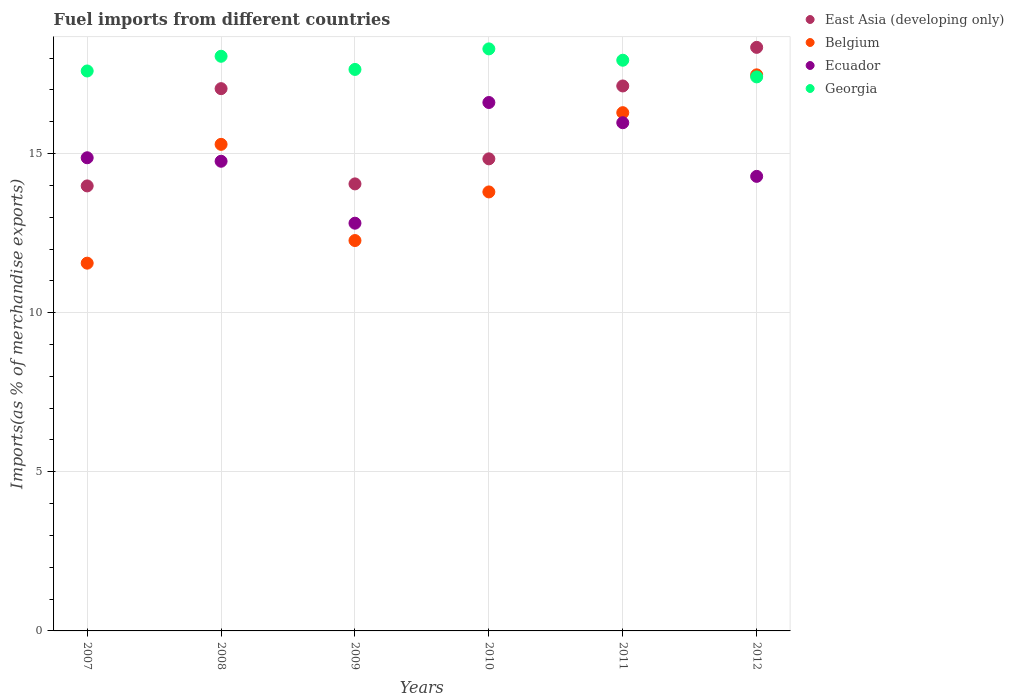Is the number of dotlines equal to the number of legend labels?
Provide a succinct answer. Yes. What is the percentage of imports to different countries in Belgium in 2009?
Your response must be concise. 12.27. Across all years, what is the maximum percentage of imports to different countries in East Asia (developing only)?
Provide a short and direct response. 18.34. Across all years, what is the minimum percentage of imports to different countries in East Asia (developing only)?
Ensure brevity in your answer.  13.98. In which year was the percentage of imports to different countries in Ecuador minimum?
Give a very brief answer. 2009. What is the total percentage of imports to different countries in East Asia (developing only) in the graph?
Provide a succinct answer. 95.36. What is the difference between the percentage of imports to different countries in Ecuador in 2009 and that in 2010?
Offer a terse response. -3.79. What is the difference between the percentage of imports to different countries in Belgium in 2009 and the percentage of imports to different countries in Ecuador in 2008?
Your response must be concise. -2.49. What is the average percentage of imports to different countries in Belgium per year?
Keep it short and to the point. 14.44. In the year 2009, what is the difference between the percentage of imports to different countries in Belgium and percentage of imports to different countries in Ecuador?
Your answer should be compact. -0.54. In how many years, is the percentage of imports to different countries in Ecuador greater than 2 %?
Offer a very short reply. 6. What is the ratio of the percentage of imports to different countries in Belgium in 2007 to that in 2011?
Make the answer very short. 0.71. Is the percentage of imports to different countries in Belgium in 2007 less than that in 2009?
Give a very brief answer. Yes. What is the difference between the highest and the second highest percentage of imports to different countries in Ecuador?
Your answer should be compact. 0.64. What is the difference between the highest and the lowest percentage of imports to different countries in Ecuador?
Your response must be concise. 3.79. Is it the case that in every year, the sum of the percentage of imports to different countries in East Asia (developing only) and percentage of imports to different countries in Belgium  is greater than the sum of percentage of imports to different countries in Ecuador and percentage of imports to different countries in Georgia?
Your response must be concise. No. Does the percentage of imports to different countries in Ecuador monotonically increase over the years?
Keep it short and to the point. No. Is the percentage of imports to different countries in Georgia strictly greater than the percentage of imports to different countries in Ecuador over the years?
Give a very brief answer. Yes. Is the percentage of imports to different countries in Georgia strictly less than the percentage of imports to different countries in East Asia (developing only) over the years?
Offer a terse response. No. How many dotlines are there?
Keep it short and to the point. 4. What is the difference between two consecutive major ticks on the Y-axis?
Your response must be concise. 5. Does the graph contain grids?
Your answer should be compact. Yes. How are the legend labels stacked?
Your answer should be very brief. Vertical. What is the title of the graph?
Provide a short and direct response. Fuel imports from different countries. Does "Faeroe Islands" appear as one of the legend labels in the graph?
Keep it short and to the point. No. What is the label or title of the Y-axis?
Make the answer very short. Imports(as % of merchandise exports). What is the Imports(as % of merchandise exports) of East Asia (developing only) in 2007?
Provide a succinct answer. 13.98. What is the Imports(as % of merchandise exports) of Belgium in 2007?
Make the answer very short. 11.56. What is the Imports(as % of merchandise exports) of Ecuador in 2007?
Your response must be concise. 14.87. What is the Imports(as % of merchandise exports) in Georgia in 2007?
Provide a short and direct response. 17.59. What is the Imports(as % of merchandise exports) of East Asia (developing only) in 2008?
Ensure brevity in your answer.  17.04. What is the Imports(as % of merchandise exports) in Belgium in 2008?
Your answer should be very brief. 15.29. What is the Imports(as % of merchandise exports) in Ecuador in 2008?
Keep it short and to the point. 14.76. What is the Imports(as % of merchandise exports) of Georgia in 2008?
Offer a very short reply. 18.06. What is the Imports(as % of merchandise exports) in East Asia (developing only) in 2009?
Make the answer very short. 14.05. What is the Imports(as % of merchandise exports) of Belgium in 2009?
Your answer should be compact. 12.27. What is the Imports(as % of merchandise exports) of Ecuador in 2009?
Offer a very short reply. 12.81. What is the Imports(as % of merchandise exports) in Georgia in 2009?
Provide a short and direct response. 17.64. What is the Imports(as % of merchandise exports) of East Asia (developing only) in 2010?
Your response must be concise. 14.83. What is the Imports(as % of merchandise exports) in Belgium in 2010?
Your answer should be very brief. 13.79. What is the Imports(as % of merchandise exports) in Ecuador in 2010?
Your answer should be very brief. 16.6. What is the Imports(as % of merchandise exports) in Georgia in 2010?
Keep it short and to the point. 18.29. What is the Imports(as % of merchandise exports) of East Asia (developing only) in 2011?
Provide a short and direct response. 17.12. What is the Imports(as % of merchandise exports) in Belgium in 2011?
Keep it short and to the point. 16.28. What is the Imports(as % of merchandise exports) in Ecuador in 2011?
Make the answer very short. 15.97. What is the Imports(as % of merchandise exports) of Georgia in 2011?
Your response must be concise. 17.93. What is the Imports(as % of merchandise exports) of East Asia (developing only) in 2012?
Give a very brief answer. 18.34. What is the Imports(as % of merchandise exports) in Belgium in 2012?
Your answer should be very brief. 17.47. What is the Imports(as % of merchandise exports) in Ecuador in 2012?
Your answer should be compact. 14.28. What is the Imports(as % of merchandise exports) in Georgia in 2012?
Give a very brief answer. 17.41. Across all years, what is the maximum Imports(as % of merchandise exports) of East Asia (developing only)?
Offer a very short reply. 18.34. Across all years, what is the maximum Imports(as % of merchandise exports) in Belgium?
Give a very brief answer. 17.47. Across all years, what is the maximum Imports(as % of merchandise exports) in Ecuador?
Keep it short and to the point. 16.6. Across all years, what is the maximum Imports(as % of merchandise exports) in Georgia?
Offer a very short reply. 18.29. Across all years, what is the minimum Imports(as % of merchandise exports) in East Asia (developing only)?
Ensure brevity in your answer.  13.98. Across all years, what is the minimum Imports(as % of merchandise exports) in Belgium?
Provide a short and direct response. 11.56. Across all years, what is the minimum Imports(as % of merchandise exports) in Ecuador?
Keep it short and to the point. 12.81. Across all years, what is the minimum Imports(as % of merchandise exports) in Georgia?
Offer a very short reply. 17.41. What is the total Imports(as % of merchandise exports) in East Asia (developing only) in the graph?
Your answer should be very brief. 95.36. What is the total Imports(as % of merchandise exports) in Belgium in the graph?
Provide a short and direct response. 86.66. What is the total Imports(as % of merchandise exports) of Ecuador in the graph?
Keep it short and to the point. 89.29. What is the total Imports(as % of merchandise exports) in Georgia in the graph?
Provide a succinct answer. 106.92. What is the difference between the Imports(as % of merchandise exports) in East Asia (developing only) in 2007 and that in 2008?
Give a very brief answer. -3.06. What is the difference between the Imports(as % of merchandise exports) of Belgium in 2007 and that in 2008?
Ensure brevity in your answer.  -3.73. What is the difference between the Imports(as % of merchandise exports) of Ecuador in 2007 and that in 2008?
Make the answer very short. 0.11. What is the difference between the Imports(as % of merchandise exports) of Georgia in 2007 and that in 2008?
Make the answer very short. -0.46. What is the difference between the Imports(as % of merchandise exports) of East Asia (developing only) in 2007 and that in 2009?
Your response must be concise. -0.06. What is the difference between the Imports(as % of merchandise exports) in Belgium in 2007 and that in 2009?
Your answer should be compact. -0.71. What is the difference between the Imports(as % of merchandise exports) of Ecuador in 2007 and that in 2009?
Your answer should be compact. 2.06. What is the difference between the Imports(as % of merchandise exports) of Georgia in 2007 and that in 2009?
Provide a succinct answer. -0.05. What is the difference between the Imports(as % of merchandise exports) in East Asia (developing only) in 2007 and that in 2010?
Your answer should be compact. -0.85. What is the difference between the Imports(as % of merchandise exports) of Belgium in 2007 and that in 2010?
Give a very brief answer. -2.24. What is the difference between the Imports(as % of merchandise exports) in Ecuador in 2007 and that in 2010?
Provide a short and direct response. -1.74. What is the difference between the Imports(as % of merchandise exports) in Georgia in 2007 and that in 2010?
Offer a terse response. -0.69. What is the difference between the Imports(as % of merchandise exports) in East Asia (developing only) in 2007 and that in 2011?
Your answer should be compact. -3.14. What is the difference between the Imports(as % of merchandise exports) of Belgium in 2007 and that in 2011?
Provide a succinct answer. -4.73. What is the difference between the Imports(as % of merchandise exports) in Ecuador in 2007 and that in 2011?
Your answer should be very brief. -1.1. What is the difference between the Imports(as % of merchandise exports) in Georgia in 2007 and that in 2011?
Give a very brief answer. -0.34. What is the difference between the Imports(as % of merchandise exports) of East Asia (developing only) in 2007 and that in 2012?
Keep it short and to the point. -4.35. What is the difference between the Imports(as % of merchandise exports) in Belgium in 2007 and that in 2012?
Provide a short and direct response. -5.92. What is the difference between the Imports(as % of merchandise exports) of Ecuador in 2007 and that in 2012?
Keep it short and to the point. 0.58. What is the difference between the Imports(as % of merchandise exports) in Georgia in 2007 and that in 2012?
Your answer should be compact. 0.19. What is the difference between the Imports(as % of merchandise exports) in East Asia (developing only) in 2008 and that in 2009?
Your answer should be compact. 2.99. What is the difference between the Imports(as % of merchandise exports) of Belgium in 2008 and that in 2009?
Your answer should be very brief. 3.02. What is the difference between the Imports(as % of merchandise exports) in Ecuador in 2008 and that in 2009?
Provide a succinct answer. 1.95. What is the difference between the Imports(as % of merchandise exports) of Georgia in 2008 and that in 2009?
Your response must be concise. 0.41. What is the difference between the Imports(as % of merchandise exports) of East Asia (developing only) in 2008 and that in 2010?
Keep it short and to the point. 2.21. What is the difference between the Imports(as % of merchandise exports) of Belgium in 2008 and that in 2010?
Make the answer very short. 1.49. What is the difference between the Imports(as % of merchandise exports) in Ecuador in 2008 and that in 2010?
Offer a terse response. -1.85. What is the difference between the Imports(as % of merchandise exports) of Georgia in 2008 and that in 2010?
Your response must be concise. -0.23. What is the difference between the Imports(as % of merchandise exports) in East Asia (developing only) in 2008 and that in 2011?
Offer a terse response. -0.08. What is the difference between the Imports(as % of merchandise exports) in Belgium in 2008 and that in 2011?
Your answer should be compact. -1. What is the difference between the Imports(as % of merchandise exports) in Ecuador in 2008 and that in 2011?
Your answer should be compact. -1.21. What is the difference between the Imports(as % of merchandise exports) of Georgia in 2008 and that in 2011?
Make the answer very short. 0.12. What is the difference between the Imports(as % of merchandise exports) in East Asia (developing only) in 2008 and that in 2012?
Give a very brief answer. -1.3. What is the difference between the Imports(as % of merchandise exports) in Belgium in 2008 and that in 2012?
Give a very brief answer. -2.18. What is the difference between the Imports(as % of merchandise exports) of Ecuador in 2008 and that in 2012?
Make the answer very short. 0.47. What is the difference between the Imports(as % of merchandise exports) in Georgia in 2008 and that in 2012?
Make the answer very short. 0.65. What is the difference between the Imports(as % of merchandise exports) of East Asia (developing only) in 2009 and that in 2010?
Your answer should be very brief. -0.79. What is the difference between the Imports(as % of merchandise exports) of Belgium in 2009 and that in 2010?
Your response must be concise. -1.53. What is the difference between the Imports(as % of merchandise exports) of Ecuador in 2009 and that in 2010?
Provide a short and direct response. -3.79. What is the difference between the Imports(as % of merchandise exports) of Georgia in 2009 and that in 2010?
Offer a very short reply. -0.65. What is the difference between the Imports(as % of merchandise exports) in East Asia (developing only) in 2009 and that in 2011?
Give a very brief answer. -3.08. What is the difference between the Imports(as % of merchandise exports) of Belgium in 2009 and that in 2011?
Your answer should be compact. -4.02. What is the difference between the Imports(as % of merchandise exports) in Ecuador in 2009 and that in 2011?
Provide a succinct answer. -3.16. What is the difference between the Imports(as % of merchandise exports) in Georgia in 2009 and that in 2011?
Ensure brevity in your answer.  -0.29. What is the difference between the Imports(as % of merchandise exports) in East Asia (developing only) in 2009 and that in 2012?
Make the answer very short. -4.29. What is the difference between the Imports(as % of merchandise exports) in Belgium in 2009 and that in 2012?
Give a very brief answer. -5.21. What is the difference between the Imports(as % of merchandise exports) in Ecuador in 2009 and that in 2012?
Offer a terse response. -1.47. What is the difference between the Imports(as % of merchandise exports) in Georgia in 2009 and that in 2012?
Keep it short and to the point. 0.23. What is the difference between the Imports(as % of merchandise exports) in East Asia (developing only) in 2010 and that in 2011?
Keep it short and to the point. -2.29. What is the difference between the Imports(as % of merchandise exports) of Belgium in 2010 and that in 2011?
Your response must be concise. -2.49. What is the difference between the Imports(as % of merchandise exports) in Ecuador in 2010 and that in 2011?
Provide a succinct answer. 0.64. What is the difference between the Imports(as % of merchandise exports) of Georgia in 2010 and that in 2011?
Your response must be concise. 0.36. What is the difference between the Imports(as % of merchandise exports) of East Asia (developing only) in 2010 and that in 2012?
Provide a short and direct response. -3.5. What is the difference between the Imports(as % of merchandise exports) of Belgium in 2010 and that in 2012?
Your response must be concise. -3.68. What is the difference between the Imports(as % of merchandise exports) in Ecuador in 2010 and that in 2012?
Ensure brevity in your answer.  2.32. What is the difference between the Imports(as % of merchandise exports) of Georgia in 2010 and that in 2012?
Provide a succinct answer. 0.88. What is the difference between the Imports(as % of merchandise exports) in East Asia (developing only) in 2011 and that in 2012?
Your response must be concise. -1.21. What is the difference between the Imports(as % of merchandise exports) of Belgium in 2011 and that in 2012?
Make the answer very short. -1.19. What is the difference between the Imports(as % of merchandise exports) of Ecuador in 2011 and that in 2012?
Your response must be concise. 1.69. What is the difference between the Imports(as % of merchandise exports) in Georgia in 2011 and that in 2012?
Provide a short and direct response. 0.52. What is the difference between the Imports(as % of merchandise exports) in East Asia (developing only) in 2007 and the Imports(as % of merchandise exports) in Belgium in 2008?
Keep it short and to the point. -1.31. What is the difference between the Imports(as % of merchandise exports) of East Asia (developing only) in 2007 and the Imports(as % of merchandise exports) of Ecuador in 2008?
Provide a succinct answer. -0.78. What is the difference between the Imports(as % of merchandise exports) of East Asia (developing only) in 2007 and the Imports(as % of merchandise exports) of Georgia in 2008?
Keep it short and to the point. -4.07. What is the difference between the Imports(as % of merchandise exports) in Belgium in 2007 and the Imports(as % of merchandise exports) in Ecuador in 2008?
Offer a terse response. -3.2. What is the difference between the Imports(as % of merchandise exports) of Belgium in 2007 and the Imports(as % of merchandise exports) of Georgia in 2008?
Ensure brevity in your answer.  -6.5. What is the difference between the Imports(as % of merchandise exports) in Ecuador in 2007 and the Imports(as % of merchandise exports) in Georgia in 2008?
Your response must be concise. -3.19. What is the difference between the Imports(as % of merchandise exports) in East Asia (developing only) in 2007 and the Imports(as % of merchandise exports) in Belgium in 2009?
Keep it short and to the point. 1.72. What is the difference between the Imports(as % of merchandise exports) of East Asia (developing only) in 2007 and the Imports(as % of merchandise exports) of Ecuador in 2009?
Your response must be concise. 1.17. What is the difference between the Imports(as % of merchandise exports) in East Asia (developing only) in 2007 and the Imports(as % of merchandise exports) in Georgia in 2009?
Your answer should be very brief. -3.66. What is the difference between the Imports(as % of merchandise exports) of Belgium in 2007 and the Imports(as % of merchandise exports) of Ecuador in 2009?
Offer a terse response. -1.26. What is the difference between the Imports(as % of merchandise exports) of Belgium in 2007 and the Imports(as % of merchandise exports) of Georgia in 2009?
Offer a terse response. -6.09. What is the difference between the Imports(as % of merchandise exports) in Ecuador in 2007 and the Imports(as % of merchandise exports) in Georgia in 2009?
Provide a short and direct response. -2.78. What is the difference between the Imports(as % of merchandise exports) in East Asia (developing only) in 2007 and the Imports(as % of merchandise exports) in Belgium in 2010?
Give a very brief answer. 0.19. What is the difference between the Imports(as % of merchandise exports) of East Asia (developing only) in 2007 and the Imports(as % of merchandise exports) of Ecuador in 2010?
Ensure brevity in your answer.  -2.62. What is the difference between the Imports(as % of merchandise exports) of East Asia (developing only) in 2007 and the Imports(as % of merchandise exports) of Georgia in 2010?
Keep it short and to the point. -4.31. What is the difference between the Imports(as % of merchandise exports) in Belgium in 2007 and the Imports(as % of merchandise exports) in Ecuador in 2010?
Provide a short and direct response. -5.05. What is the difference between the Imports(as % of merchandise exports) in Belgium in 2007 and the Imports(as % of merchandise exports) in Georgia in 2010?
Your answer should be very brief. -6.73. What is the difference between the Imports(as % of merchandise exports) in Ecuador in 2007 and the Imports(as % of merchandise exports) in Georgia in 2010?
Provide a short and direct response. -3.42. What is the difference between the Imports(as % of merchandise exports) in East Asia (developing only) in 2007 and the Imports(as % of merchandise exports) in Belgium in 2011?
Offer a terse response. -2.3. What is the difference between the Imports(as % of merchandise exports) of East Asia (developing only) in 2007 and the Imports(as % of merchandise exports) of Ecuador in 2011?
Provide a succinct answer. -1.99. What is the difference between the Imports(as % of merchandise exports) in East Asia (developing only) in 2007 and the Imports(as % of merchandise exports) in Georgia in 2011?
Ensure brevity in your answer.  -3.95. What is the difference between the Imports(as % of merchandise exports) of Belgium in 2007 and the Imports(as % of merchandise exports) of Ecuador in 2011?
Ensure brevity in your answer.  -4.41. What is the difference between the Imports(as % of merchandise exports) in Belgium in 2007 and the Imports(as % of merchandise exports) in Georgia in 2011?
Provide a short and direct response. -6.38. What is the difference between the Imports(as % of merchandise exports) of Ecuador in 2007 and the Imports(as % of merchandise exports) of Georgia in 2011?
Your answer should be compact. -3.06. What is the difference between the Imports(as % of merchandise exports) in East Asia (developing only) in 2007 and the Imports(as % of merchandise exports) in Belgium in 2012?
Keep it short and to the point. -3.49. What is the difference between the Imports(as % of merchandise exports) in East Asia (developing only) in 2007 and the Imports(as % of merchandise exports) in Ecuador in 2012?
Your answer should be compact. -0.3. What is the difference between the Imports(as % of merchandise exports) of East Asia (developing only) in 2007 and the Imports(as % of merchandise exports) of Georgia in 2012?
Offer a very short reply. -3.43. What is the difference between the Imports(as % of merchandise exports) in Belgium in 2007 and the Imports(as % of merchandise exports) in Ecuador in 2012?
Ensure brevity in your answer.  -2.73. What is the difference between the Imports(as % of merchandise exports) of Belgium in 2007 and the Imports(as % of merchandise exports) of Georgia in 2012?
Ensure brevity in your answer.  -5.85. What is the difference between the Imports(as % of merchandise exports) in Ecuador in 2007 and the Imports(as % of merchandise exports) in Georgia in 2012?
Give a very brief answer. -2.54. What is the difference between the Imports(as % of merchandise exports) of East Asia (developing only) in 2008 and the Imports(as % of merchandise exports) of Belgium in 2009?
Your answer should be very brief. 4.77. What is the difference between the Imports(as % of merchandise exports) in East Asia (developing only) in 2008 and the Imports(as % of merchandise exports) in Ecuador in 2009?
Offer a very short reply. 4.23. What is the difference between the Imports(as % of merchandise exports) of East Asia (developing only) in 2008 and the Imports(as % of merchandise exports) of Georgia in 2009?
Ensure brevity in your answer.  -0.6. What is the difference between the Imports(as % of merchandise exports) of Belgium in 2008 and the Imports(as % of merchandise exports) of Ecuador in 2009?
Offer a very short reply. 2.48. What is the difference between the Imports(as % of merchandise exports) in Belgium in 2008 and the Imports(as % of merchandise exports) in Georgia in 2009?
Give a very brief answer. -2.35. What is the difference between the Imports(as % of merchandise exports) of Ecuador in 2008 and the Imports(as % of merchandise exports) of Georgia in 2009?
Give a very brief answer. -2.89. What is the difference between the Imports(as % of merchandise exports) in East Asia (developing only) in 2008 and the Imports(as % of merchandise exports) in Belgium in 2010?
Ensure brevity in your answer.  3.24. What is the difference between the Imports(as % of merchandise exports) of East Asia (developing only) in 2008 and the Imports(as % of merchandise exports) of Ecuador in 2010?
Your response must be concise. 0.44. What is the difference between the Imports(as % of merchandise exports) of East Asia (developing only) in 2008 and the Imports(as % of merchandise exports) of Georgia in 2010?
Your answer should be very brief. -1.25. What is the difference between the Imports(as % of merchandise exports) in Belgium in 2008 and the Imports(as % of merchandise exports) in Ecuador in 2010?
Make the answer very short. -1.31. What is the difference between the Imports(as % of merchandise exports) of Belgium in 2008 and the Imports(as % of merchandise exports) of Georgia in 2010?
Provide a short and direct response. -3. What is the difference between the Imports(as % of merchandise exports) of Ecuador in 2008 and the Imports(as % of merchandise exports) of Georgia in 2010?
Offer a terse response. -3.53. What is the difference between the Imports(as % of merchandise exports) in East Asia (developing only) in 2008 and the Imports(as % of merchandise exports) in Belgium in 2011?
Your answer should be very brief. 0.75. What is the difference between the Imports(as % of merchandise exports) of East Asia (developing only) in 2008 and the Imports(as % of merchandise exports) of Ecuador in 2011?
Keep it short and to the point. 1.07. What is the difference between the Imports(as % of merchandise exports) in East Asia (developing only) in 2008 and the Imports(as % of merchandise exports) in Georgia in 2011?
Provide a short and direct response. -0.89. What is the difference between the Imports(as % of merchandise exports) in Belgium in 2008 and the Imports(as % of merchandise exports) in Ecuador in 2011?
Your response must be concise. -0.68. What is the difference between the Imports(as % of merchandise exports) of Belgium in 2008 and the Imports(as % of merchandise exports) of Georgia in 2011?
Give a very brief answer. -2.64. What is the difference between the Imports(as % of merchandise exports) in Ecuador in 2008 and the Imports(as % of merchandise exports) in Georgia in 2011?
Offer a very short reply. -3.17. What is the difference between the Imports(as % of merchandise exports) of East Asia (developing only) in 2008 and the Imports(as % of merchandise exports) of Belgium in 2012?
Ensure brevity in your answer.  -0.43. What is the difference between the Imports(as % of merchandise exports) of East Asia (developing only) in 2008 and the Imports(as % of merchandise exports) of Ecuador in 2012?
Ensure brevity in your answer.  2.76. What is the difference between the Imports(as % of merchandise exports) of East Asia (developing only) in 2008 and the Imports(as % of merchandise exports) of Georgia in 2012?
Your answer should be very brief. -0.37. What is the difference between the Imports(as % of merchandise exports) in Belgium in 2008 and the Imports(as % of merchandise exports) in Georgia in 2012?
Your response must be concise. -2.12. What is the difference between the Imports(as % of merchandise exports) in Ecuador in 2008 and the Imports(as % of merchandise exports) in Georgia in 2012?
Provide a succinct answer. -2.65. What is the difference between the Imports(as % of merchandise exports) of East Asia (developing only) in 2009 and the Imports(as % of merchandise exports) of Belgium in 2010?
Your response must be concise. 0.25. What is the difference between the Imports(as % of merchandise exports) in East Asia (developing only) in 2009 and the Imports(as % of merchandise exports) in Ecuador in 2010?
Keep it short and to the point. -2.56. What is the difference between the Imports(as % of merchandise exports) in East Asia (developing only) in 2009 and the Imports(as % of merchandise exports) in Georgia in 2010?
Make the answer very short. -4.24. What is the difference between the Imports(as % of merchandise exports) of Belgium in 2009 and the Imports(as % of merchandise exports) of Ecuador in 2010?
Make the answer very short. -4.34. What is the difference between the Imports(as % of merchandise exports) in Belgium in 2009 and the Imports(as % of merchandise exports) in Georgia in 2010?
Give a very brief answer. -6.02. What is the difference between the Imports(as % of merchandise exports) of Ecuador in 2009 and the Imports(as % of merchandise exports) of Georgia in 2010?
Your response must be concise. -5.48. What is the difference between the Imports(as % of merchandise exports) in East Asia (developing only) in 2009 and the Imports(as % of merchandise exports) in Belgium in 2011?
Your answer should be compact. -2.24. What is the difference between the Imports(as % of merchandise exports) in East Asia (developing only) in 2009 and the Imports(as % of merchandise exports) in Ecuador in 2011?
Offer a terse response. -1.92. What is the difference between the Imports(as % of merchandise exports) of East Asia (developing only) in 2009 and the Imports(as % of merchandise exports) of Georgia in 2011?
Ensure brevity in your answer.  -3.89. What is the difference between the Imports(as % of merchandise exports) of Belgium in 2009 and the Imports(as % of merchandise exports) of Ecuador in 2011?
Offer a very short reply. -3.7. What is the difference between the Imports(as % of merchandise exports) in Belgium in 2009 and the Imports(as % of merchandise exports) in Georgia in 2011?
Your answer should be very brief. -5.67. What is the difference between the Imports(as % of merchandise exports) of Ecuador in 2009 and the Imports(as % of merchandise exports) of Georgia in 2011?
Offer a very short reply. -5.12. What is the difference between the Imports(as % of merchandise exports) in East Asia (developing only) in 2009 and the Imports(as % of merchandise exports) in Belgium in 2012?
Your answer should be compact. -3.43. What is the difference between the Imports(as % of merchandise exports) in East Asia (developing only) in 2009 and the Imports(as % of merchandise exports) in Ecuador in 2012?
Your answer should be very brief. -0.24. What is the difference between the Imports(as % of merchandise exports) of East Asia (developing only) in 2009 and the Imports(as % of merchandise exports) of Georgia in 2012?
Your answer should be compact. -3.36. What is the difference between the Imports(as % of merchandise exports) in Belgium in 2009 and the Imports(as % of merchandise exports) in Ecuador in 2012?
Your answer should be compact. -2.02. What is the difference between the Imports(as % of merchandise exports) in Belgium in 2009 and the Imports(as % of merchandise exports) in Georgia in 2012?
Your answer should be compact. -5.14. What is the difference between the Imports(as % of merchandise exports) in Ecuador in 2009 and the Imports(as % of merchandise exports) in Georgia in 2012?
Your answer should be very brief. -4.6. What is the difference between the Imports(as % of merchandise exports) in East Asia (developing only) in 2010 and the Imports(as % of merchandise exports) in Belgium in 2011?
Keep it short and to the point. -1.45. What is the difference between the Imports(as % of merchandise exports) in East Asia (developing only) in 2010 and the Imports(as % of merchandise exports) in Ecuador in 2011?
Keep it short and to the point. -1.14. What is the difference between the Imports(as % of merchandise exports) of East Asia (developing only) in 2010 and the Imports(as % of merchandise exports) of Georgia in 2011?
Ensure brevity in your answer.  -3.1. What is the difference between the Imports(as % of merchandise exports) in Belgium in 2010 and the Imports(as % of merchandise exports) in Ecuador in 2011?
Offer a terse response. -2.17. What is the difference between the Imports(as % of merchandise exports) in Belgium in 2010 and the Imports(as % of merchandise exports) in Georgia in 2011?
Your answer should be compact. -4.14. What is the difference between the Imports(as % of merchandise exports) of Ecuador in 2010 and the Imports(as % of merchandise exports) of Georgia in 2011?
Offer a terse response. -1.33. What is the difference between the Imports(as % of merchandise exports) of East Asia (developing only) in 2010 and the Imports(as % of merchandise exports) of Belgium in 2012?
Provide a succinct answer. -2.64. What is the difference between the Imports(as % of merchandise exports) in East Asia (developing only) in 2010 and the Imports(as % of merchandise exports) in Ecuador in 2012?
Keep it short and to the point. 0.55. What is the difference between the Imports(as % of merchandise exports) of East Asia (developing only) in 2010 and the Imports(as % of merchandise exports) of Georgia in 2012?
Give a very brief answer. -2.58. What is the difference between the Imports(as % of merchandise exports) in Belgium in 2010 and the Imports(as % of merchandise exports) in Ecuador in 2012?
Offer a very short reply. -0.49. What is the difference between the Imports(as % of merchandise exports) in Belgium in 2010 and the Imports(as % of merchandise exports) in Georgia in 2012?
Your answer should be compact. -3.61. What is the difference between the Imports(as % of merchandise exports) of Ecuador in 2010 and the Imports(as % of merchandise exports) of Georgia in 2012?
Keep it short and to the point. -0.8. What is the difference between the Imports(as % of merchandise exports) in East Asia (developing only) in 2011 and the Imports(as % of merchandise exports) in Belgium in 2012?
Give a very brief answer. -0.35. What is the difference between the Imports(as % of merchandise exports) in East Asia (developing only) in 2011 and the Imports(as % of merchandise exports) in Ecuador in 2012?
Offer a terse response. 2.84. What is the difference between the Imports(as % of merchandise exports) of East Asia (developing only) in 2011 and the Imports(as % of merchandise exports) of Georgia in 2012?
Provide a succinct answer. -0.28. What is the difference between the Imports(as % of merchandise exports) of Belgium in 2011 and the Imports(as % of merchandise exports) of Ecuador in 2012?
Provide a succinct answer. 2. What is the difference between the Imports(as % of merchandise exports) of Belgium in 2011 and the Imports(as % of merchandise exports) of Georgia in 2012?
Make the answer very short. -1.12. What is the difference between the Imports(as % of merchandise exports) of Ecuador in 2011 and the Imports(as % of merchandise exports) of Georgia in 2012?
Make the answer very short. -1.44. What is the average Imports(as % of merchandise exports) of East Asia (developing only) per year?
Provide a succinct answer. 15.89. What is the average Imports(as % of merchandise exports) in Belgium per year?
Your response must be concise. 14.44. What is the average Imports(as % of merchandise exports) in Ecuador per year?
Offer a terse response. 14.88. What is the average Imports(as % of merchandise exports) of Georgia per year?
Provide a succinct answer. 17.82. In the year 2007, what is the difference between the Imports(as % of merchandise exports) in East Asia (developing only) and Imports(as % of merchandise exports) in Belgium?
Your response must be concise. 2.43. In the year 2007, what is the difference between the Imports(as % of merchandise exports) in East Asia (developing only) and Imports(as % of merchandise exports) in Ecuador?
Your answer should be compact. -0.88. In the year 2007, what is the difference between the Imports(as % of merchandise exports) of East Asia (developing only) and Imports(as % of merchandise exports) of Georgia?
Your answer should be very brief. -3.61. In the year 2007, what is the difference between the Imports(as % of merchandise exports) in Belgium and Imports(as % of merchandise exports) in Ecuador?
Your answer should be compact. -3.31. In the year 2007, what is the difference between the Imports(as % of merchandise exports) in Belgium and Imports(as % of merchandise exports) in Georgia?
Ensure brevity in your answer.  -6.04. In the year 2007, what is the difference between the Imports(as % of merchandise exports) in Ecuador and Imports(as % of merchandise exports) in Georgia?
Give a very brief answer. -2.73. In the year 2008, what is the difference between the Imports(as % of merchandise exports) of East Asia (developing only) and Imports(as % of merchandise exports) of Belgium?
Your answer should be compact. 1.75. In the year 2008, what is the difference between the Imports(as % of merchandise exports) of East Asia (developing only) and Imports(as % of merchandise exports) of Ecuador?
Your answer should be compact. 2.28. In the year 2008, what is the difference between the Imports(as % of merchandise exports) of East Asia (developing only) and Imports(as % of merchandise exports) of Georgia?
Your answer should be very brief. -1.02. In the year 2008, what is the difference between the Imports(as % of merchandise exports) of Belgium and Imports(as % of merchandise exports) of Ecuador?
Keep it short and to the point. 0.53. In the year 2008, what is the difference between the Imports(as % of merchandise exports) in Belgium and Imports(as % of merchandise exports) in Georgia?
Your answer should be compact. -2.77. In the year 2008, what is the difference between the Imports(as % of merchandise exports) of Ecuador and Imports(as % of merchandise exports) of Georgia?
Your response must be concise. -3.3. In the year 2009, what is the difference between the Imports(as % of merchandise exports) in East Asia (developing only) and Imports(as % of merchandise exports) in Belgium?
Make the answer very short. 1.78. In the year 2009, what is the difference between the Imports(as % of merchandise exports) of East Asia (developing only) and Imports(as % of merchandise exports) of Ecuador?
Keep it short and to the point. 1.23. In the year 2009, what is the difference between the Imports(as % of merchandise exports) in East Asia (developing only) and Imports(as % of merchandise exports) in Georgia?
Make the answer very short. -3.6. In the year 2009, what is the difference between the Imports(as % of merchandise exports) of Belgium and Imports(as % of merchandise exports) of Ecuador?
Give a very brief answer. -0.54. In the year 2009, what is the difference between the Imports(as % of merchandise exports) in Belgium and Imports(as % of merchandise exports) in Georgia?
Make the answer very short. -5.38. In the year 2009, what is the difference between the Imports(as % of merchandise exports) in Ecuador and Imports(as % of merchandise exports) in Georgia?
Your answer should be compact. -4.83. In the year 2010, what is the difference between the Imports(as % of merchandise exports) of East Asia (developing only) and Imports(as % of merchandise exports) of Belgium?
Provide a succinct answer. 1.04. In the year 2010, what is the difference between the Imports(as % of merchandise exports) of East Asia (developing only) and Imports(as % of merchandise exports) of Ecuador?
Your response must be concise. -1.77. In the year 2010, what is the difference between the Imports(as % of merchandise exports) in East Asia (developing only) and Imports(as % of merchandise exports) in Georgia?
Make the answer very short. -3.46. In the year 2010, what is the difference between the Imports(as % of merchandise exports) of Belgium and Imports(as % of merchandise exports) of Ecuador?
Your response must be concise. -2.81. In the year 2010, what is the difference between the Imports(as % of merchandise exports) in Belgium and Imports(as % of merchandise exports) in Georgia?
Give a very brief answer. -4.49. In the year 2010, what is the difference between the Imports(as % of merchandise exports) in Ecuador and Imports(as % of merchandise exports) in Georgia?
Provide a succinct answer. -1.68. In the year 2011, what is the difference between the Imports(as % of merchandise exports) of East Asia (developing only) and Imports(as % of merchandise exports) of Belgium?
Offer a terse response. 0.84. In the year 2011, what is the difference between the Imports(as % of merchandise exports) of East Asia (developing only) and Imports(as % of merchandise exports) of Ecuador?
Offer a very short reply. 1.15. In the year 2011, what is the difference between the Imports(as % of merchandise exports) of East Asia (developing only) and Imports(as % of merchandise exports) of Georgia?
Provide a short and direct response. -0.81. In the year 2011, what is the difference between the Imports(as % of merchandise exports) of Belgium and Imports(as % of merchandise exports) of Ecuador?
Offer a very short reply. 0.32. In the year 2011, what is the difference between the Imports(as % of merchandise exports) in Belgium and Imports(as % of merchandise exports) in Georgia?
Keep it short and to the point. -1.65. In the year 2011, what is the difference between the Imports(as % of merchandise exports) of Ecuador and Imports(as % of merchandise exports) of Georgia?
Offer a very short reply. -1.96. In the year 2012, what is the difference between the Imports(as % of merchandise exports) of East Asia (developing only) and Imports(as % of merchandise exports) of Belgium?
Give a very brief answer. 0.86. In the year 2012, what is the difference between the Imports(as % of merchandise exports) in East Asia (developing only) and Imports(as % of merchandise exports) in Ecuador?
Provide a succinct answer. 4.05. In the year 2012, what is the difference between the Imports(as % of merchandise exports) of East Asia (developing only) and Imports(as % of merchandise exports) of Georgia?
Provide a succinct answer. 0.93. In the year 2012, what is the difference between the Imports(as % of merchandise exports) in Belgium and Imports(as % of merchandise exports) in Ecuador?
Offer a very short reply. 3.19. In the year 2012, what is the difference between the Imports(as % of merchandise exports) in Belgium and Imports(as % of merchandise exports) in Georgia?
Keep it short and to the point. 0.06. In the year 2012, what is the difference between the Imports(as % of merchandise exports) of Ecuador and Imports(as % of merchandise exports) of Georgia?
Give a very brief answer. -3.13. What is the ratio of the Imports(as % of merchandise exports) of East Asia (developing only) in 2007 to that in 2008?
Your response must be concise. 0.82. What is the ratio of the Imports(as % of merchandise exports) of Belgium in 2007 to that in 2008?
Offer a terse response. 0.76. What is the ratio of the Imports(as % of merchandise exports) of Ecuador in 2007 to that in 2008?
Ensure brevity in your answer.  1.01. What is the ratio of the Imports(as % of merchandise exports) in Georgia in 2007 to that in 2008?
Provide a succinct answer. 0.97. What is the ratio of the Imports(as % of merchandise exports) in Belgium in 2007 to that in 2009?
Ensure brevity in your answer.  0.94. What is the ratio of the Imports(as % of merchandise exports) in Ecuador in 2007 to that in 2009?
Provide a succinct answer. 1.16. What is the ratio of the Imports(as % of merchandise exports) of East Asia (developing only) in 2007 to that in 2010?
Your answer should be compact. 0.94. What is the ratio of the Imports(as % of merchandise exports) of Belgium in 2007 to that in 2010?
Give a very brief answer. 0.84. What is the ratio of the Imports(as % of merchandise exports) in Ecuador in 2007 to that in 2010?
Give a very brief answer. 0.9. What is the ratio of the Imports(as % of merchandise exports) of Georgia in 2007 to that in 2010?
Provide a succinct answer. 0.96. What is the ratio of the Imports(as % of merchandise exports) of East Asia (developing only) in 2007 to that in 2011?
Keep it short and to the point. 0.82. What is the ratio of the Imports(as % of merchandise exports) in Belgium in 2007 to that in 2011?
Ensure brevity in your answer.  0.71. What is the ratio of the Imports(as % of merchandise exports) of Georgia in 2007 to that in 2011?
Your answer should be very brief. 0.98. What is the ratio of the Imports(as % of merchandise exports) of East Asia (developing only) in 2007 to that in 2012?
Your response must be concise. 0.76. What is the ratio of the Imports(as % of merchandise exports) in Belgium in 2007 to that in 2012?
Give a very brief answer. 0.66. What is the ratio of the Imports(as % of merchandise exports) in Ecuador in 2007 to that in 2012?
Provide a succinct answer. 1.04. What is the ratio of the Imports(as % of merchandise exports) in Georgia in 2007 to that in 2012?
Offer a very short reply. 1.01. What is the ratio of the Imports(as % of merchandise exports) of East Asia (developing only) in 2008 to that in 2009?
Give a very brief answer. 1.21. What is the ratio of the Imports(as % of merchandise exports) of Belgium in 2008 to that in 2009?
Your answer should be very brief. 1.25. What is the ratio of the Imports(as % of merchandise exports) in Ecuador in 2008 to that in 2009?
Make the answer very short. 1.15. What is the ratio of the Imports(as % of merchandise exports) of Georgia in 2008 to that in 2009?
Provide a succinct answer. 1.02. What is the ratio of the Imports(as % of merchandise exports) of East Asia (developing only) in 2008 to that in 2010?
Ensure brevity in your answer.  1.15. What is the ratio of the Imports(as % of merchandise exports) of Belgium in 2008 to that in 2010?
Make the answer very short. 1.11. What is the ratio of the Imports(as % of merchandise exports) of Ecuador in 2008 to that in 2010?
Offer a very short reply. 0.89. What is the ratio of the Imports(as % of merchandise exports) of Georgia in 2008 to that in 2010?
Ensure brevity in your answer.  0.99. What is the ratio of the Imports(as % of merchandise exports) of East Asia (developing only) in 2008 to that in 2011?
Make the answer very short. 1. What is the ratio of the Imports(as % of merchandise exports) of Belgium in 2008 to that in 2011?
Your answer should be very brief. 0.94. What is the ratio of the Imports(as % of merchandise exports) of Ecuador in 2008 to that in 2011?
Provide a short and direct response. 0.92. What is the ratio of the Imports(as % of merchandise exports) in East Asia (developing only) in 2008 to that in 2012?
Your answer should be very brief. 0.93. What is the ratio of the Imports(as % of merchandise exports) in Ecuador in 2008 to that in 2012?
Offer a terse response. 1.03. What is the ratio of the Imports(as % of merchandise exports) of Georgia in 2008 to that in 2012?
Provide a succinct answer. 1.04. What is the ratio of the Imports(as % of merchandise exports) in East Asia (developing only) in 2009 to that in 2010?
Offer a terse response. 0.95. What is the ratio of the Imports(as % of merchandise exports) in Belgium in 2009 to that in 2010?
Offer a very short reply. 0.89. What is the ratio of the Imports(as % of merchandise exports) in Ecuador in 2009 to that in 2010?
Your answer should be compact. 0.77. What is the ratio of the Imports(as % of merchandise exports) of Georgia in 2009 to that in 2010?
Offer a terse response. 0.96. What is the ratio of the Imports(as % of merchandise exports) in East Asia (developing only) in 2009 to that in 2011?
Offer a very short reply. 0.82. What is the ratio of the Imports(as % of merchandise exports) in Belgium in 2009 to that in 2011?
Provide a short and direct response. 0.75. What is the ratio of the Imports(as % of merchandise exports) in Ecuador in 2009 to that in 2011?
Ensure brevity in your answer.  0.8. What is the ratio of the Imports(as % of merchandise exports) of Georgia in 2009 to that in 2011?
Make the answer very short. 0.98. What is the ratio of the Imports(as % of merchandise exports) in East Asia (developing only) in 2009 to that in 2012?
Provide a short and direct response. 0.77. What is the ratio of the Imports(as % of merchandise exports) of Belgium in 2009 to that in 2012?
Ensure brevity in your answer.  0.7. What is the ratio of the Imports(as % of merchandise exports) of Ecuador in 2009 to that in 2012?
Offer a terse response. 0.9. What is the ratio of the Imports(as % of merchandise exports) in Georgia in 2009 to that in 2012?
Offer a terse response. 1.01. What is the ratio of the Imports(as % of merchandise exports) in East Asia (developing only) in 2010 to that in 2011?
Your answer should be compact. 0.87. What is the ratio of the Imports(as % of merchandise exports) of Belgium in 2010 to that in 2011?
Make the answer very short. 0.85. What is the ratio of the Imports(as % of merchandise exports) in Ecuador in 2010 to that in 2011?
Your answer should be compact. 1.04. What is the ratio of the Imports(as % of merchandise exports) of Georgia in 2010 to that in 2011?
Provide a succinct answer. 1.02. What is the ratio of the Imports(as % of merchandise exports) in East Asia (developing only) in 2010 to that in 2012?
Offer a terse response. 0.81. What is the ratio of the Imports(as % of merchandise exports) in Belgium in 2010 to that in 2012?
Offer a very short reply. 0.79. What is the ratio of the Imports(as % of merchandise exports) in Ecuador in 2010 to that in 2012?
Give a very brief answer. 1.16. What is the ratio of the Imports(as % of merchandise exports) in Georgia in 2010 to that in 2012?
Ensure brevity in your answer.  1.05. What is the ratio of the Imports(as % of merchandise exports) in East Asia (developing only) in 2011 to that in 2012?
Provide a succinct answer. 0.93. What is the ratio of the Imports(as % of merchandise exports) in Belgium in 2011 to that in 2012?
Give a very brief answer. 0.93. What is the ratio of the Imports(as % of merchandise exports) in Ecuador in 2011 to that in 2012?
Offer a terse response. 1.12. What is the ratio of the Imports(as % of merchandise exports) of Georgia in 2011 to that in 2012?
Your answer should be very brief. 1.03. What is the difference between the highest and the second highest Imports(as % of merchandise exports) of East Asia (developing only)?
Ensure brevity in your answer.  1.21. What is the difference between the highest and the second highest Imports(as % of merchandise exports) in Belgium?
Give a very brief answer. 1.19. What is the difference between the highest and the second highest Imports(as % of merchandise exports) of Ecuador?
Provide a short and direct response. 0.64. What is the difference between the highest and the second highest Imports(as % of merchandise exports) in Georgia?
Your answer should be compact. 0.23. What is the difference between the highest and the lowest Imports(as % of merchandise exports) of East Asia (developing only)?
Your answer should be very brief. 4.35. What is the difference between the highest and the lowest Imports(as % of merchandise exports) of Belgium?
Your answer should be compact. 5.92. What is the difference between the highest and the lowest Imports(as % of merchandise exports) in Ecuador?
Keep it short and to the point. 3.79. What is the difference between the highest and the lowest Imports(as % of merchandise exports) in Georgia?
Offer a very short reply. 0.88. 